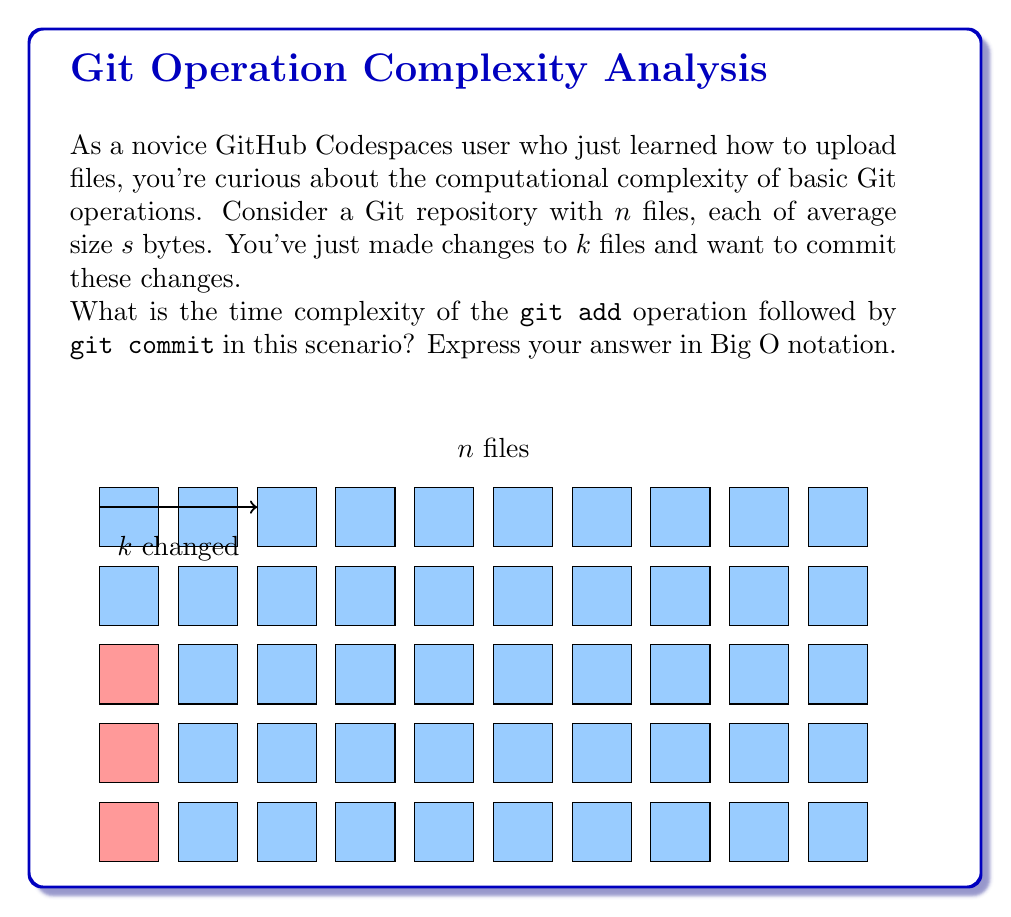Show me your answer to this math problem. Let's break this down step-by-step:

1) The `git add` operation:
   - Git needs to hash each changed file to create a blob object.
   - Hashing a file takes time proportional to its size.
   - We have $k$ changed files, each of size $s$.
   - Time complexity for `git add`: $O(k \cdot s)$

2) The `git commit` operation:
   - Git creates a new tree object representing the current state of the repository.
   - It needs to traverse all $n$ files in the repository.
   - For each file, it either uses the existing hash (for unchanged files) or the new hash (for changed files).
   - Creating the commit object itself is a constant time operation.
   - Time complexity for `git commit`: $O(n)$

3) Combining the two operations:
   - Total time complexity: $O(k \cdot s + n)$

4) Simplification:
   - In the worst case, all files are changed: $k = n$
   - This gives us: $O(n \cdot s + n)$
   - We can factor out $n$: $O(n \cdot (s + 1))$
   - Since $s$ is typically much larger than 1, we can simplify to: $O(n \cdot s)$

Therefore, the overall time complexity is $O(n \cdot s)$, where $n$ is the number of files and $s$ is the average file size.
Answer: $O(n \cdot s)$ 